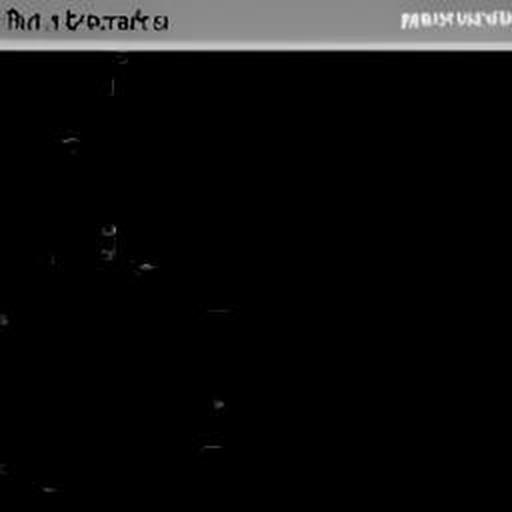Are there any quality issues with this image? Yes, the image is extremely dark and lacks visible content, which could be due to underexposure or a technical malfunction. This severely impacts its clarity and the ability to discern any details from the photo. 